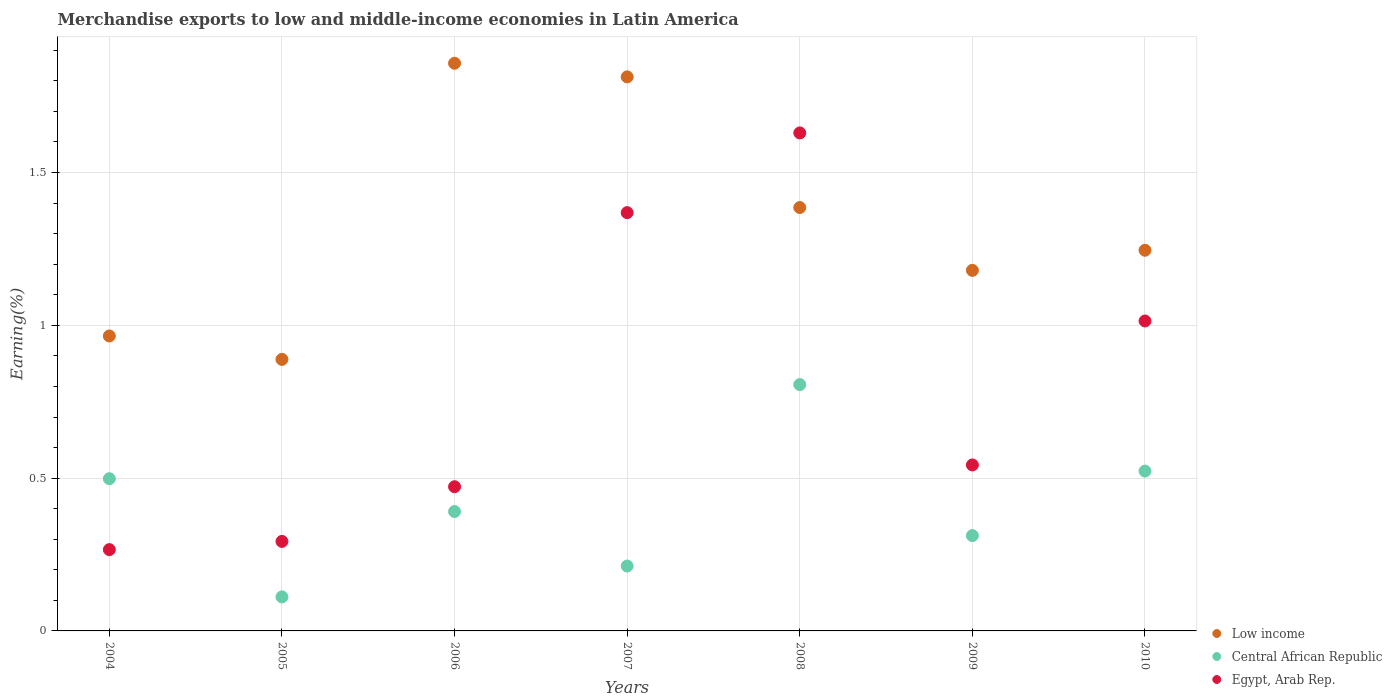How many different coloured dotlines are there?
Offer a very short reply. 3. What is the percentage of amount earned from merchandise exports in Egypt, Arab Rep. in 2010?
Provide a short and direct response. 1.01. Across all years, what is the maximum percentage of amount earned from merchandise exports in Low income?
Your response must be concise. 1.86. Across all years, what is the minimum percentage of amount earned from merchandise exports in Central African Republic?
Offer a very short reply. 0.11. In which year was the percentage of amount earned from merchandise exports in Central African Republic minimum?
Your response must be concise. 2005. What is the total percentage of amount earned from merchandise exports in Low income in the graph?
Your answer should be compact. 9.34. What is the difference between the percentage of amount earned from merchandise exports in Egypt, Arab Rep. in 2006 and that in 2009?
Offer a very short reply. -0.07. What is the difference between the percentage of amount earned from merchandise exports in Egypt, Arab Rep. in 2004 and the percentage of amount earned from merchandise exports in Low income in 2010?
Offer a very short reply. -0.98. What is the average percentage of amount earned from merchandise exports in Low income per year?
Ensure brevity in your answer.  1.33. In the year 2008, what is the difference between the percentage of amount earned from merchandise exports in Central African Republic and percentage of amount earned from merchandise exports in Egypt, Arab Rep.?
Offer a very short reply. -0.82. What is the ratio of the percentage of amount earned from merchandise exports in Low income in 2004 to that in 2006?
Your answer should be very brief. 0.52. Is the difference between the percentage of amount earned from merchandise exports in Central African Republic in 2004 and 2010 greater than the difference between the percentage of amount earned from merchandise exports in Egypt, Arab Rep. in 2004 and 2010?
Your answer should be very brief. Yes. What is the difference between the highest and the second highest percentage of amount earned from merchandise exports in Egypt, Arab Rep.?
Offer a very short reply. 0.26. What is the difference between the highest and the lowest percentage of amount earned from merchandise exports in Egypt, Arab Rep.?
Offer a very short reply. 1.36. Is the percentage of amount earned from merchandise exports in Egypt, Arab Rep. strictly greater than the percentage of amount earned from merchandise exports in Central African Republic over the years?
Offer a terse response. No. How many dotlines are there?
Give a very brief answer. 3. What is the difference between two consecutive major ticks on the Y-axis?
Ensure brevity in your answer.  0.5. Are the values on the major ticks of Y-axis written in scientific E-notation?
Ensure brevity in your answer.  No. Does the graph contain any zero values?
Offer a terse response. No. Does the graph contain grids?
Your answer should be very brief. Yes. Where does the legend appear in the graph?
Offer a terse response. Bottom right. What is the title of the graph?
Offer a terse response. Merchandise exports to low and middle-income economies in Latin America. Does "Papua New Guinea" appear as one of the legend labels in the graph?
Provide a succinct answer. No. What is the label or title of the X-axis?
Keep it short and to the point. Years. What is the label or title of the Y-axis?
Make the answer very short. Earning(%). What is the Earning(%) of Low income in 2004?
Offer a very short reply. 0.97. What is the Earning(%) of Central African Republic in 2004?
Ensure brevity in your answer.  0.5. What is the Earning(%) in Egypt, Arab Rep. in 2004?
Ensure brevity in your answer.  0.27. What is the Earning(%) of Low income in 2005?
Give a very brief answer. 0.89. What is the Earning(%) in Central African Republic in 2005?
Your response must be concise. 0.11. What is the Earning(%) in Egypt, Arab Rep. in 2005?
Make the answer very short. 0.29. What is the Earning(%) in Low income in 2006?
Provide a succinct answer. 1.86. What is the Earning(%) of Central African Republic in 2006?
Your answer should be very brief. 0.39. What is the Earning(%) of Egypt, Arab Rep. in 2006?
Offer a very short reply. 0.47. What is the Earning(%) of Low income in 2007?
Offer a terse response. 1.81. What is the Earning(%) in Central African Republic in 2007?
Ensure brevity in your answer.  0.21. What is the Earning(%) in Egypt, Arab Rep. in 2007?
Make the answer very short. 1.37. What is the Earning(%) of Low income in 2008?
Your answer should be very brief. 1.39. What is the Earning(%) of Central African Republic in 2008?
Provide a short and direct response. 0.81. What is the Earning(%) in Egypt, Arab Rep. in 2008?
Offer a terse response. 1.63. What is the Earning(%) of Low income in 2009?
Offer a very short reply. 1.18. What is the Earning(%) in Central African Republic in 2009?
Ensure brevity in your answer.  0.31. What is the Earning(%) of Egypt, Arab Rep. in 2009?
Provide a short and direct response. 0.54. What is the Earning(%) in Low income in 2010?
Offer a terse response. 1.25. What is the Earning(%) in Central African Republic in 2010?
Offer a very short reply. 0.52. What is the Earning(%) of Egypt, Arab Rep. in 2010?
Your answer should be compact. 1.01. Across all years, what is the maximum Earning(%) of Low income?
Provide a succinct answer. 1.86. Across all years, what is the maximum Earning(%) of Central African Republic?
Keep it short and to the point. 0.81. Across all years, what is the maximum Earning(%) in Egypt, Arab Rep.?
Offer a very short reply. 1.63. Across all years, what is the minimum Earning(%) in Low income?
Make the answer very short. 0.89. Across all years, what is the minimum Earning(%) of Central African Republic?
Your response must be concise. 0.11. Across all years, what is the minimum Earning(%) in Egypt, Arab Rep.?
Keep it short and to the point. 0.27. What is the total Earning(%) in Low income in the graph?
Offer a terse response. 9.34. What is the total Earning(%) in Central African Republic in the graph?
Provide a short and direct response. 2.85. What is the total Earning(%) of Egypt, Arab Rep. in the graph?
Ensure brevity in your answer.  5.59. What is the difference between the Earning(%) of Low income in 2004 and that in 2005?
Keep it short and to the point. 0.08. What is the difference between the Earning(%) in Central African Republic in 2004 and that in 2005?
Your answer should be compact. 0.39. What is the difference between the Earning(%) in Egypt, Arab Rep. in 2004 and that in 2005?
Your response must be concise. -0.03. What is the difference between the Earning(%) of Low income in 2004 and that in 2006?
Your answer should be very brief. -0.89. What is the difference between the Earning(%) in Central African Republic in 2004 and that in 2006?
Make the answer very short. 0.11. What is the difference between the Earning(%) of Egypt, Arab Rep. in 2004 and that in 2006?
Offer a terse response. -0.21. What is the difference between the Earning(%) in Low income in 2004 and that in 2007?
Offer a terse response. -0.85. What is the difference between the Earning(%) of Central African Republic in 2004 and that in 2007?
Make the answer very short. 0.29. What is the difference between the Earning(%) of Egypt, Arab Rep. in 2004 and that in 2007?
Give a very brief answer. -1.1. What is the difference between the Earning(%) in Low income in 2004 and that in 2008?
Your response must be concise. -0.42. What is the difference between the Earning(%) in Central African Republic in 2004 and that in 2008?
Provide a short and direct response. -0.31. What is the difference between the Earning(%) in Egypt, Arab Rep. in 2004 and that in 2008?
Your response must be concise. -1.36. What is the difference between the Earning(%) in Low income in 2004 and that in 2009?
Your answer should be very brief. -0.21. What is the difference between the Earning(%) of Central African Republic in 2004 and that in 2009?
Make the answer very short. 0.19. What is the difference between the Earning(%) in Egypt, Arab Rep. in 2004 and that in 2009?
Ensure brevity in your answer.  -0.28. What is the difference between the Earning(%) of Low income in 2004 and that in 2010?
Your answer should be compact. -0.28. What is the difference between the Earning(%) of Central African Republic in 2004 and that in 2010?
Offer a terse response. -0.02. What is the difference between the Earning(%) of Egypt, Arab Rep. in 2004 and that in 2010?
Your response must be concise. -0.75. What is the difference between the Earning(%) of Low income in 2005 and that in 2006?
Ensure brevity in your answer.  -0.97. What is the difference between the Earning(%) of Central African Republic in 2005 and that in 2006?
Your answer should be compact. -0.28. What is the difference between the Earning(%) in Egypt, Arab Rep. in 2005 and that in 2006?
Your response must be concise. -0.18. What is the difference between the Earning(%) of Low income in 2005 and that in 2007?
Keep it short and to the point. -0.92. What is the difference between the Earning(%) of Central African Republic in 2005 and that in 2007?
Offer a very short reply. -0.1. What is the difference between the Earning(%) in Egypt, Arab Rep. in 2005 and that in 2007?
Keep it short and to the point. -1.08. What is the difference between the Earning(%) in Low income in 2005 and that in 2008?
Offer a terse response. -0.5. What is the difference between the Earning(%) of Central African Republic in 2005 and that in 2008?
Give a very brief answer. -0.69. What is the difference between the Earning(%) of Egypt, Arab Rep. in 2005 and that in 2008?
Ensure brevity in your answer.  -1.34. What is the difference between the Earning(%) of Low income in 2005 and that in 2009?
Provide a short and direct response. -0.29. What is the difference between the Earning(%) of Central African Republic in 2005 and that in 2009?
Give a very brief answer. -0.2. What is the difference between the Earning(%) of Egypt, Arab Rep. in 2005 and that in 2009?
Offer a very short reply. -0.25. What is the difference between the Earning(%) of Low income in 2005 and that in 2010?
Make the answer very short. -0.36. What is the difference between the Earning(%) in Central African Republic in 2005 and that in 2010?
Ensure brevity in your answer.  -0.41. What is the difference between the Earning(%) of Egypt, Arab Rep. in 2005 and that in 2010?
Provide a succinct answer. -0.72. What is the difference between the Earning(%) of Low income in 2006 and that in 2007?
Your answer should be compact. 0.04. What is the difference between the Earning(%) of Central African Republic in 2006 and that in 2007?
Offer a very short reply. 0.18. What is the difference between the Earning(%) in Egypt, Arab Rep. in 2006 and that in 2007?
Provide a short and direct response. -0.9. What is the difference between the Earning(%) of Low income in 2006 and that in 2008?
Offer a very short reply. 0.47. What is the difference between the Earning(%) in Central African Republic in 2006 and that in 2008?
Your response must be concise. -0.42. What is the difference between the Earning(%) in Egypt, Arab Rep. in 2006 and that in 2008?
Your response must be concise. -1.16. What is the difference between the Earning(%) in Low income in 2006 and that in 2009?
Your answer should be compact. 0.68. What is the difference between the Earning(%) in Central African Republic in 2006 and that in 2009?
Ensure brevity in your answer.  0.08. What is the difference between the Earning(%) in Egypt, Arab Rep. in 2006 and that in 2009?
Give a very brief answer. -0.07. What is the difference between the Earning(%) in Low income in 2006 and that in 2010?
Your answer should be compact. 0.61. What is the difference between the Earning(%) in Central African Republic in 2006 and that in 2010?
Offer a terse response. -0.13. What is the difference between the Earning(%) in Egypt, Arab Rep. in 2006 and that in 2010?
Your answer should be very brief. -0.54. What is the difference between the Earning(%) in Low income in 2007 and that in 2008?
Provide a short and direct response. 0.43. What is the difference between the Earning(%) of Central African Republic in 2007 and that in 2008?
Give a very brief answer. -0.59. What is the difference between the Earning(%) in Egypt, Arab Rep. in 2007 and that in 2008?
Offer a terse response. -0.26. What is the difference between the Earning(%) of Low income in 2007 and that in 2009?
Provide a succinct answer. 0.63. What is the difference between the Earning(%) in Central African Republic in 2007 and that in 2009?
Keep it short and to the point. -0.1. What is the difference between the Earning(%) in Egypt, Arab Rep. in 2007 and that in 2009?
Make the answer very short. 0.83. What is the difference between the Earning(%) of Low income in 2007 and that in 2010?
Provide a short and direct response. 0.57. What is the difference between the Earning(%) of Central African Republic in 2007 and that in 2010?
Your response must be concise. -0.31. What is the difference between the Earning(%) of Egypt, Arab Rep. in 2007 and that in 2010?
Your answer should be compact. 0.35. What is the difference between the Earning(%) in Low income in 2008 and that in 2009?
Make the answer very short. 0.21. What is the difference between the Earning(%) in Central African Republic in 2008 and that in 2009?
Your answer should be very brief. 0.49. What is the difference between the Earning(%) of Egypt, Arab Rep. in 2008 and that in 2009?
Your response must be concise. 1.09. What is the difference between the Earning(%) in Low income in 2008 and that in 2010?
Provide a succinct answer. 0.14. What is the difference between the Earning(%) in Central African Republic in 2008 and that in 2010?
Provide a short and direct response. 0.28. What is the difference between the Earning(%) in Egypt, Arab Rep. in 2008 and that in 2010?
Provide a succinct answer. 0.62. What is the difference between the Earning(%) of Low income in 2009 and that in 2010?
Ensure brevity in your answer.  -0.07. What is the difference between the Earning(%) in Central African Republic in 2009 and that in 2010?
Make the answer very short. -0.21. What is the difference between the Earning(%) in Egypt, Arab Rep. in 2009 and that in 2010?
Keep it short and to the point. -0.47. What is the difference between the Earning(%) in Low income in 2004 and the Earning(%) in Central African Republic in 2005?
Make the answer very short. 0.85. What is the difference between the Earning(%) of Low income in 2004 and the Earning(%) of Egypt, Arab Rep. in 2005?
Provide a short and direct response. 0.67. What is the difference between the Earning(%) of Central African Republic in 2004 and the Earning(%) of Egypt, Arab Rep. in 2005?
Make the answer very short. 0.21. What is the difference between the Earning(%) in Low income in 2004 and the Earning(%) in Central African Republic in 2006?
Ensure brevity in your answer.  0.57. What is the difference between the Earning(%) of Low income in 2004 and the Earning(%) of Egypt, Arab Rep. in 2006?
Your answer should be compact. 0.49. What is the difference between the Earning(%) of Central African Republic in 2004 and the Earning(%) of Egypt, Arab Rep. in 2006?
Ensure brevity in your answer.  0.03. What is the difference between the Earning(%) in Low income in 2004 and the Earning(%) in Central African Republic in 2007?
Provide a succinct answer. 0.75. What is the difference between the Earning(%) of Low income in 2004 and the Earning(%) of Egypt, Arab Rep. in 2007?
Provide a succinct answer. -0.4. What is the difference between the Earning(%) in Central African Republic in 2004 and the Earning(%) in Egypt, Arab Rep. in 2007?
Give a very brief answer. -0.87. What is the difference between the Earning(%) of Low income in 2004 and the Earning(%) of Central African Republic in 2008?
Offer a terse response. 0.16. What is the difference between the Earning(%) in Low income in 2004 and the Earning(%) in Egypt, Arab Rep. in 2008?
Ensure brevity in your answer.  -0.66. What is the difference between the Earning(%) of Central African Republic in 2004 and the Earning(%) of Egypt, Arab Rep. in 2008?
Make the answer very short. -1.13. What is the difference between the Earning(%) of Low income in 2004 and the Earning(%) of Central African Republic in 2009?
Offer a terse response. 0.65. What is the difference between the Earning(%) in Low income in 2004 and the Earning(%) in Egypt, Arab Rep. in 2009?
Your response must be concise. 0.42. What is the difference between the Earning(%) of Central African Republic in 2004 and the Earning(%) of Egypt, Arab Rep. in 2009?
Provide a short and direct response. -0.04. What is the difference between the Earning(%) in Low income in 2004 and the Earning(%) in Central African Republic in 2010?
Make the answer very short. 0.44. What is the difference between the Earning(%) of Low income in 2004 and the Earning(%) of Egypt, Arab Rep. in 2010?
Your answer should be very brief. -0.05. What is the difference between the Earning(%) of Central African Republic in 2004 and the Earning(%) of Egypt, Arab Rep. in 2010?
Give a very brief answer. -0.52. What is the difference between the Earning(%) of Low income in 2005 and the Earning(%) of Central African Republic in 2006?
Your answer should be compact. 0.5. What is the difference between the Earning(%) in Low income in 2005 and the Earning(%) in Egypt, Arab Rep. in 2006?
Offer a very short reply. 0.42. What is the difference between the Earning(%) of Central African Republic in 2005 and the Earning(%) of Egypt, Arab Rep. in 2006?
Provide a succinct answer. -0.36. What is the difference between the Earning(%) in Low income in 2005 and the Earning(%) in Central African Republic in 2007?
Your answer should be very brief. 0.68. What is the difference between the Earning(%) in Low income in 2005 and the Earning(%) in Egypt, Arab Rep. in 2007?
Your answer should be very brief. -0.48. What is the difference between the Earning(%) in Central African Republic in 2005 and the Earning(%) in Egypt, Arab Rep. in 2007?
Offer a terse response. -1.26. What is the difference between the Earning(%) of Low income in 2005 and the Earning(%) of Central African Republic in 2008?
Offer a terse response. 0.08. What is the difference between the Earning(%) in Low income in 2005 and the Earning(%) in Egypt, Arab Rep. in 2008?
Provide a succinct answer. -0.74. What is the difference between the Earning(%) of Central African Republic in 2005 and the Earning(%) of Egypt, Arab Rep. in 2008?
Provide a succinct answer. -1.52. What is the difference between the Earning(%) of Low income in 2005 and the Earning(%) of Central African Republic in 2009?
Keep it short and to the point. 0.58. What is the difference between the Earning(%) of Low income in 2005 and the Earning(%) of Egypt, Arab Rep. in 2009?
Offer a very short reply. 0.35. What is the difference between the Earning(%) of Central African Republic in 2005 and the Earning(%) of Egypt, Arab Rep. in 2009?
Your answer should be compact. -0.43. What is the difference between the Earning(%) of Low income in 2005 and the Earning(%) of Central African Republic in 2010?
Offer a terse response. 0.37. What is the difference between the Earning(%) of Low income in 2005 and the Earning(%) of Egypt, Arab Rep. in 2010?
Your answer should be compact. -0.13. What is the difference between the Earning(%) in Central African Republic in 2005 and the Earning(%) in Egypt, Arab Rep. in 2010?
Ensure brevity in your answer.  -0.9. What is the difference between the Earning(%) of Low income in 2006 and the Earning(%) of Central African Republic in 2007?
Offer a terse response. 1.65. What is the difference between the Earning(%) in Low income in 2006 and the Earning(%) in Egypt, Arab Rep. in 2007?
Make the answer very short. 0.49. What is the difference between the Earning(%) of Central African Republic in 2006 and the Earning(%) of Egypt, Arab Rep. in 2007?
Ensure brevity in your answer.  -0.98. What is the difference between the Earning(%) of Low income in 2006 and the Earning(%) of Central African Republic in 2008?
Offer a terse response. 1.05. What is the difference between the Earning(%) of Low income in 2006 and the Earning(%) of Egypt, Arab Rep. in 2008?
Ensure brevity in your answer.  0.23. What is the difference between the Earning(%) in Central African Republic in 2006 and the Earning(%) in Egypt, Arab Rep. in 2008?
Your response must be concise. -1.24. What is the difference between the Earning(%) in Low income in 2006 and the Earning(%) in Central African Republic in 2009?
Provide a short and direct response. 1.55. What is the difference between the Earning(%) of Low income in 2006 and the Earning(%) of Egypt, Arab Rep. in 2009?
Offer a terse response. 1.31. What is the difference between the Earning(%) of Central African Republic in 2006 and the Earning(%) of Egypt, Arab Rep. in 2009?
Offer a very short reply. -0.15. What is the difference between the Earning(%) in Low income in 2006 and the Earning(%) in Central African Republic in 2010?
Offer a very short reply. 1.33. What is the difference between the Earning(%) in Low income in 2006 and the Earning(%) in Egypt, Arab Rep. in 2010?
Your response must be concise. 0.84. What is the difference between the Earning(%) in Central African Republic in 2006 and the Earning(%) in Egypt, Arab Rep. in 2010?
Provide a succinct answer. -0.62. What is the difference between the Earning(%) of Low income in 2007 and the Earning(%) of Egypt, Arab Rep. in 2008?
Offer a terse response. 0.18. What is the difference between the Earning(%) in Central African Republic in 2007 and the Earning(%) in Egypt, Arab Rep. in 2008?
Your answer should be very brief. -1.42. What is the difference between the Earning(%) in Low income in 2007 and the Earning(%) in Central African Republic in 2009?
Your response must be concise. 1.5. What is the difference between the Earning(%) of Low income in 2007 and the Earning(%) of Egypt, Arab Rep. in 2009?
Provide a succinct answer. 1.27. What is the difference between the Earning(%) of Central African Republic in 2007 and the Earning(%) of Egypt, Arab Rep. in 2009?
Make the answer very short. -0.33. What is the difference between the Earning(%) of Low income in 2007 and the Earning(%) of Central African Republic in 2010?
Provide a succinct answer. 1.29. What is the difference between the Earning(%) in Low income in 2007 and the Earning(%) in Egypt, Arab Rep. in 2010?
Give a very brief answer. 0.8. What is the difference between the Earning(%) of Central African Republic in 2007 and the Earning(%) of Egypt, Arab Rep. in 2010?
Your answer should be very brief. -0.8. What is the difference between the Earning(%) in Low income in 2008 and the Earning(%) in Central African Republic in 2009?
Give a very brief answer. 1.07. What is the difference between the Earning(%) of Low income in 2008 and the Earning(%) of Egypt, Arab Rep. in 2009?
Make the answer very short. 0.84. What is the difference between the Earning(%) in Central African Republic in 2008 and the Earning(%) in Egypt, Arab Rep. in 2009?
Your response must be concise. 0.26. What is the difference between the Earning(%) of Low income in 2008 and the Earning(%) of Central African Republic in 2010?
Ensure brevity in your answer.  0.86. What is the difference between the Earning(%) of Low income in 2008 and the Earning(%) of Egypt, Arab Rep. in 2010?
Give a very brief answer. 0.37. What is the difference between the Earning(%) of Central African Republic in 2008 and the Earning(%) of Egypt, Arab Rep. in 2010?
Offer a terse response. -0.21. What is the difference between the Earning(%) in Low income in 2009 and the Earning(%) in Central African Republic in 2010?
Your response must be concise. 0.66. What is the difference between the Earning(%) of Low income in 2009 and the Earning(%) of Egypt, Arab Rep. in 2010?
Provide a succinct answer. 0.17. What is the difference between the Earning(%) in Central African Republic in 2009 and the Earning(%) in Egypt, Arab Rep. in 2010?
Your answer should be very brief. -0.7. What is the average Earning(%) of Low income per year?
Your response must be concise. 1.33. What is the average Earning(%) in Central African Republic per year?
Give a very brief answer. 0.41. What is the average Earning(%) of Egypt, Arab Rep. per year?
Make the answer very short. 0.8. In the year 2004, what is the difference between the Earning(%) in Low income and Earning(%) in Central African Republic?
Offer a terse response. 0.47. In the year 2004, what is the difference between the Earning(%) in Low income and Earning(%) in Egypt, Arab Rep.?
Keep it short and to the point. 0.7. In the year 2004, what is the difference between the Earning(%) in Central African Republic and Earning(%) in Egypt, Arab Rep.?
Keep it short and to the point. 0.23. In the year 2005, what is the difference between the Earning(%) of Low income and Earning(%) of Central African Republic?
Provide a succinct answer. 0.78. In the year 2005, what is the difference between the Earning(%) of Low income and Earning(%) of Egypt, Arab Rep.?
Offer a very short reply. 0.6. In the year 2005, what is the difference between the Earning(%) in Central African Republic and Earning(%) in Egypt, Arab Rep.?
Give a very brief answer. -0.18. In the year 2006, what is the difference between the Earning(%) of Low income and Earning(%) of Central African Republic?
Your response must be concise. 1.47. In the year 2006, what is the difference between the Earning(%) in Low income and Earning(%) in Egypt, Arab Rep.?
Provide a short and direct response. 1.39. In the year 2006, what is the difference between the Earning(%) of Central African Republic and Earning(%) of Egypt, Arab Rep.?
Offer a terse response. -0.08. In the year 2007, what is the difference between the Earning(%) in Low income and Earning(%) in Central African Republic?
Provide a short and direct response. 1.6. In the year 2007, what is the difference between the Earning(%) of Low income and Earning(%) of Egypt, Arab Rep.?
Provide a succinct answer. 0.44. In the year 2007, what is the difference between the Earning(%) of Central African Republic and Earning(%) of Egypt, Arab Rep.?
Offer a very short reply. -1.16. In the year 2008, what is the difference between the Earning(%) in Low income and Earning(%) in Central African Republic?
Your response must be concise. 0.58. In the year 2008, what is the difference between the Earning(%) in Low income and Earning(%) in Egypt, Arab Rep.?
Make the answer very short. -0.24. In the year 2008, what is the difference between the Earning(%) of Central African Republic and Earning(%) of Egypt, Arab Rep.?
Keep it short and to the point. -0.82. In the year 2009, what is the difference between the Earning(%) in Low income and Earning(%) in Central African Republic?
Keep it short and to the point. 0.87. In the year 2009, what is the difference between the Earning(%) in Low income and Earning(%) in Egypt, Arab Rep.?
Your answer should be very brief. 0.64. In the year 2009, what is the difference between the Earning(%) of Central African Republic and Earning(%) of Egypt, Arab Rep.?
Provide a succinct answer. -0.23. In the year 2010, what is the difference between the Earning(%) in Low income and Earning(%) in Central African Republic?
Make the answer very short. 0.72. In the year 2010, what is the difference between the Earning(%) of Low income and Earning(%) of Egypt, Arab Rep.?
Make the answer very short. 0.23. In the year 2010, what is the difference between the Earning(%) of Central African Republic and Earning(%) of Egypt, Arab Rep.?
Offer a terse response. -0.49. What is the ratio of the Earning(%) in Low income in 2004 to that in 2005?
Your response must be concise. 1.09. What is the ratio of the Earning(%) in Central African Republic in 2004 to that in 2005?
Your answer should be compact. 4.47. What is the ratio of the Earning(%) of Egypt, Arab Rep. in 2004 to that in 2005?
Provide a succinct answer. 0.91. What is the ratio of the Earning(%) in Low income in 2004 to that in 2006?
Offer a terse response. 0.52. What is the ratio of the Earning(%) of Central African Republic in 2004 to that in 2006?
Offer a very short reply. 1.27. What is the ratio of the Earning(%) of Egypt, Arab Rep. in 2004 to that in 2006?
Offer a very short reply. 0.56. What is the ratio of the Earning(%) of Low income in 2004 to that in 2007?
Make the answer very short. 0.53. What is the ratio of the Earning(%) of Central African Republic in 2004 to that in 2007?
Provide a succinct answer. 2.35. What is the ratio of the Earning(%) of Egypt, Arab Rep. in 2004 to that in 2007?
Provide a short and direct response. 0.19. What is the ratio of the Earning(%) in Low income in 2004 to that in 2008?
Offer a terse response. 0.7. What is the ratio of the Earning(%) in Central African Republic in 2004 to that in 2008?
Provide a short and direct response. 0.62. What is the ratio of the Earning(%) of Egypt, Arab Rep. in 2004 to that in 2008?
Ensure brevity in your answer.  0.16. What is the ratio of the Earning(%) of Low income in 2004 to that in 2009?
Provide a succinct answer. 0.82. What is the ratio of the Earning(%) of Central African Republic in 2004 to that in 2009?
Your answer should be compact. 1.6. What is the ratio of the Earning(%) of Egypt, Arab Rep. in 2004 to that in 2009?
Your answer should be very brief. 0.49. What is the ratio of the Earning(%) of Low income in 2004 to that in 2010?
Offer a terse response. 0.77. What is the ratio of the Earning(%) in Central African Republic in 2004 to that in 2010?
Your answer should be compact. 0.95. What is the ratio of the Earning(%) in Egypt, Arab Rep. in 2004 to that in 2010?
Provide a succinct answer. 0.26. What is the ratio of the Earning(%) of Low income in 2005 to that in 2006?
Provide a short and direct response. 0.48. What is the ratio of the Earning(%) of Central African Republic in 2005 to that in 2006?
Ensure brevity in your answer.  0.28. What is the ratio of the Earning(%) of Egypt, Arab Rep. in 2005 to that in 2006?
Ensure brevity in your answer.  0.62. What is the ratio of the Earning(%) of Low income in 2005 to that in 2007?
Your answer should be very brief. 0.49. What is the ratio of the Earning(%) of Central African Republic in 2005 to that in 2007?
Provide a short and direct response. 0.52. What is the ratio of the Earning(%) of Egypt, Arab Rep. in 2005 to that in 2007?
Provide a succinct answer. 0.21. What is the ratio of the Earning(%) of Low income in 2005 to that in 2008?
Keep it short and to the point. 0.64. What is the ratio of the Earning(%) in Central African Republic in 2005 to that in 2008?
Make the answer very short. 0.14. What is the ratio of the Earning(%) in Egypt, Arab Rep. in 2005 to that in 2008?
Your answer should be very brief. 0.18. What is the ratio of the Earning(%) in Low income in 2005 to that in 2009?
Provide a short and direct response. 0.75. What is the ratio of the Earning(%) in Central African Republic in 2005 to that in 2009?
Keep it short and to the point. 0.36. What is the ratio of the Earning(%) of Egypt, Arab Rep. in 2005 to that in 2009?
Your response must be concise. 0.54. What is the ratio of the Earning(%) of Low income in 2005 to that in 2010?
Your answer should be compact. 0.71. What is the ratio of the Earning(%) in Central African Republic in 2005 to that in 2010?
Your answer should be very brief. 0.21. What is the ratio of the Earning(%) of Egypt, Arab Rep. in 2005 to that in 2010?
Your response must be concise. 0.29. What is the ratio of the Earning(%) in Low income in 2006 to that in 2007?
Keep it short and to the point. 1.02. What is the ratio of the Earning(%) of Central African Republic in 2006 to that in 2007?
Your answer should be compact. 1.84. What is the ratio of the Earning(%) of Egypt, Arab Rep. in 2006 to that in 2007?
Your answer should be very brief. 0.34. What is the ratio of the Earning(%) of Low income in 2006 to that in 2008?
Your answer should be compact. 1.34. What is the ratio of the Earning(%) of Central African Republic in 2006 to that in 2008?
Offer a terse response. 0.48. What is the ratio of the Earning(%) of Egypt, Arab Rep. in 2006 to that in 2008?
Your answer should be very brief. 0.29. What is the ratio of the Earning(%) in Low income in 2006 to that in 2009?
Your answer should be compact. 1.57. What is the ratio of the Earning(%) in Central African Republic in 2006 to that in 2009?
Ensure brevity in your answer.  1.25. What is the ratio of the Earning(%) in Egypt, Arab Rep. in 2006 to that in 2009?
Provide a short and direct response. 0.87. What is the ratio of the Earning(%) in Low income in 2006 to that in 2010?
Your response must be concise. 1.49. What is the ratio of the Earning(%) in Central African Republic in 2006 to that in 2010?
Offer a very short reply. 0.75. What is the ratio of the Earning(%) of Egypt, Arab Rep. in 2006 to that in 2010?
Your answer should be very brief. 0.47. What is the ratio of the Earning(%) in Low income in 2007 to that in 2008?
Make the answer very short. 1.31. What is the ratio of the Earning(%) of Central African Republic in 2007 to that in 2008?
Keep it short and to the point. 0.26. What is the ratio of the Earning(%) in Egypt, Arab Rep. in 2007 to that in 2008?
Give a very brief answer. 0.84. What is the ratio of the Earning(%) of Low income in 2007 to that in 2009?
Provide a short and direct response. 1.54. What is the ratio of the Earning(%) of Central African Republic in 2007 to that in 2009?
Give a very brief answer. 0.68. What is the ratio of the Earning(%) of Egypt, Arab Rep. in 2007 to that in 2009?
Offer a very short reply. 2.52. What is the ratio of the Earning(%) in Low income in 2007 to that in 2010?
Offer a very short reply. 1.46. What is the ratio of the Earning(%) of Central African Republic in 2007 to that in 2010?
Make the answer very short. 0.41. What is the ratio of the Earning(%) of Egypt, Arab Rep. in 2007 to that in 2010?
Provide a short and direct response. 1.35. What is the ratio of the Earning(%) in Low income in 2008 to that in 2009?
Offer a very short reply. 1.17. What is the ratio of the Earning(%) of Central African Republic in 2008 to that in 2009?
Ensure brevity in your answer.  2.58. What is the ratio of the Earning(%) of Egypt, Arab Rep. in 2008 to that in 2009?
Offer a terse response. 3. What is the ratio of the Earning(%) in Low income in 2008 to that in 2010?
Provide a short and direct response. 1.11. What is the ratio of the Earning(%) of Central African Republic in 2008 to that in 2010?
Provide a succinct answer. 1.54. What is the ratio of the Earning(%) in Egypt, Arab Rep. in 2008 to that in 2010?
Provide a short and direct response. 1.61. What is the ratio of the Earning(%) in Low income in 2009 to that in 2010?
Your answer should be compact. 0.95. What is the ratio of the Earning(%) of Central African Republic in 2009 to that in 2010?
Your response must be concise. 0.6. What is the ratio of the Earning(%) in Egypt, Arab Rep. in 2009 to that in 2010?
Give a very brief answer. 0.54. What is the difference between the highest and the second highest Earning(%) of Low income?
Your answer should be compact. 0.04. What is the difference between the highest and the second highest Earning(%) of Central African Republic?
Make the answer very short. 0.28. What is the difference between the highest and the second highest Earning(%) of Egypt, Arab Rep.?
Your answer should be compact. 0.26. What is the difference between the highest and the lowest Earning(%) of Central African Republic?
Your answer should be compact. 0.69. What is the difference between the highest and the lowest Earning(%) in Egypt, Arab Rep.?
Your answer should be very brief. 1.36. 